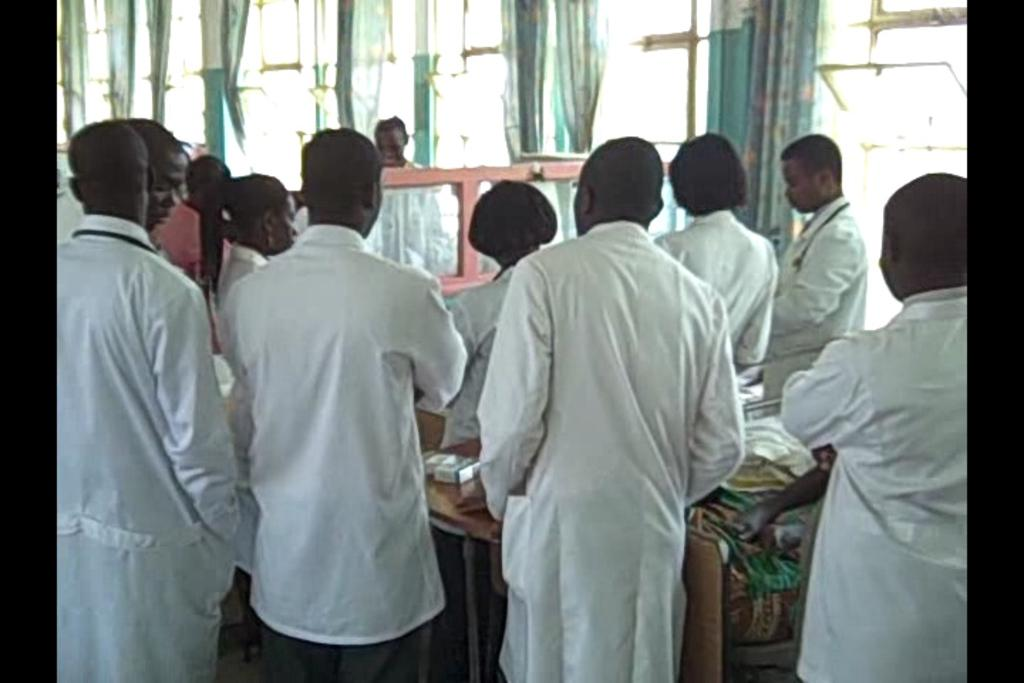How many individuals are present in the image? There are many people standing in the image. What are the people wearing? The people are wearing clothes. What type of window treatment can be seen in the image? There are curtains visible in the image. Can you describe the architectural feature that allows light and air into the room? There are windows visible in the image. How would you describe the clarity of the image? The image is slightly blurred. What type of drawer is visible in the image? There is no drawer present in the image. How much debt is being discussed by the people in the image? There is no indication of any debt being discussed in the image. 